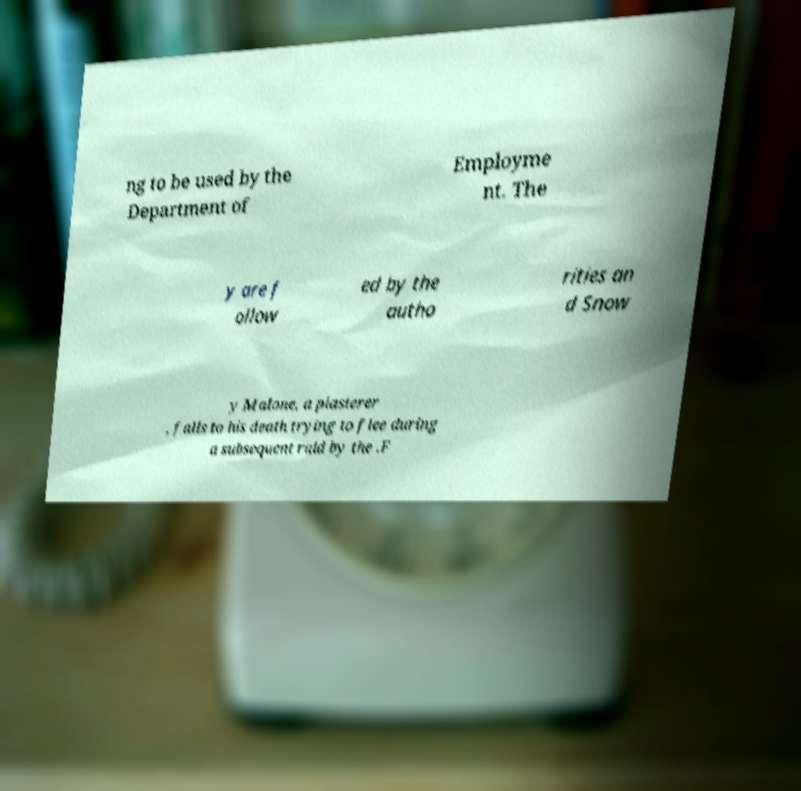For documentation purposes, I need the text within this image transcribed. Could you provide that? ng to be used by the Department of Employme nt. The y are f ollow ed by the autho rities an d Snow y Malone, a plasterer , falls to his death trying to flee during a subsequent raid by the .F 